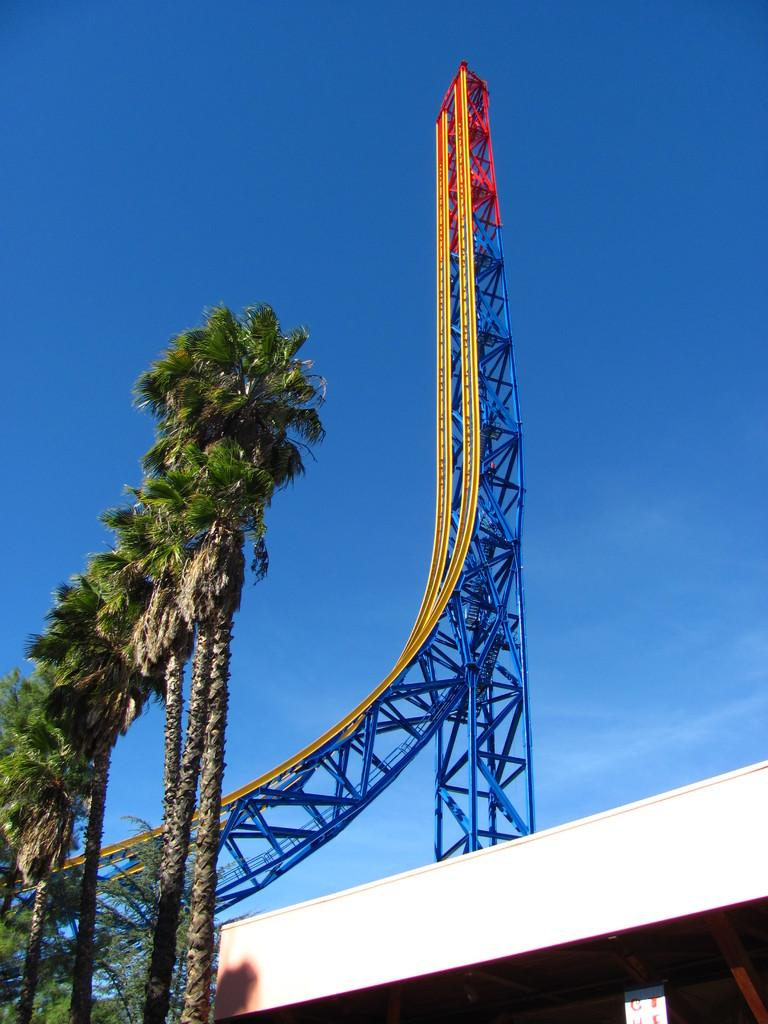What type of vegetation is on the left side of the image? There are trees on the left side of the image. What structure can be seen in the image? There is a wall in the image. What object is present in the image that might be used for displaying information or announcements? There is a board in the image. What type of attraction is visible in the image? There is a roller coaster ride in the image. What color is the sky in the background of the image? The sky in the background of the image is blue. Can you see the roof of the roller coaster in the image? There is no mention of a roof for the roller coaster in the image, so it cannot be confirmed or denied. What type of body is present in the image? There is no body, such as a human or animal, present in the image. 